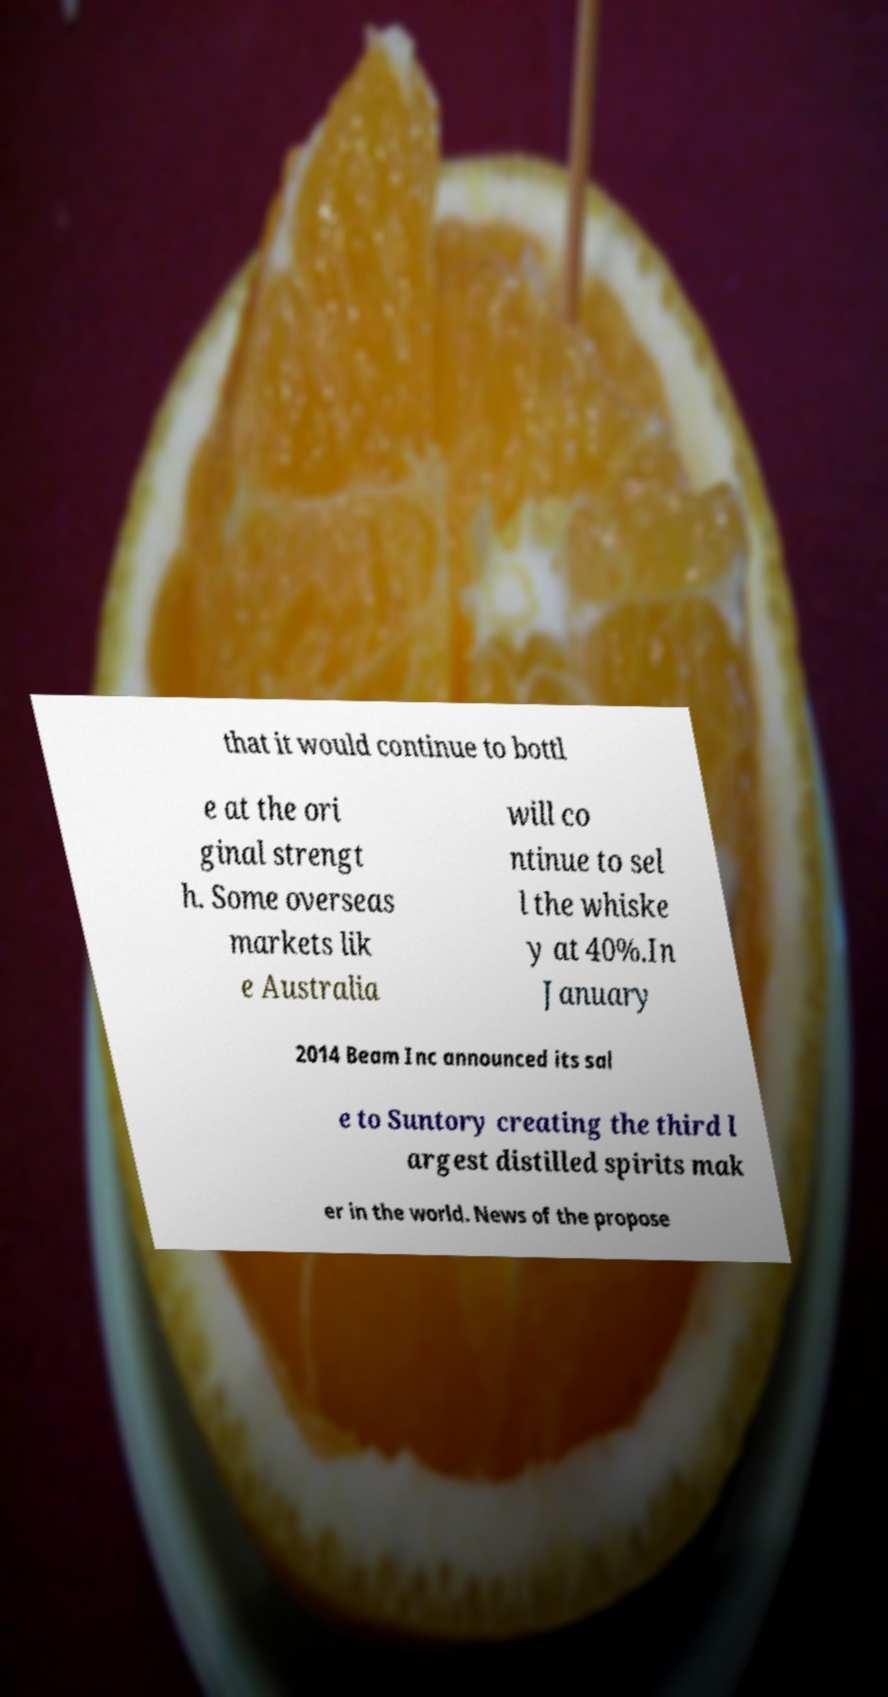For documentation purposes, I need the text within this image transcribed. Could you provide that? that it would continue to bottl e at the ori ginal strengt h. Some overseas markets lik e Australia will co ntinue to sel l the whiske y at 40%.In January 2014 Beam Inc announced its sal e to Suntory creating the third l argest distilled spirits mak er in the world. News of the propose 